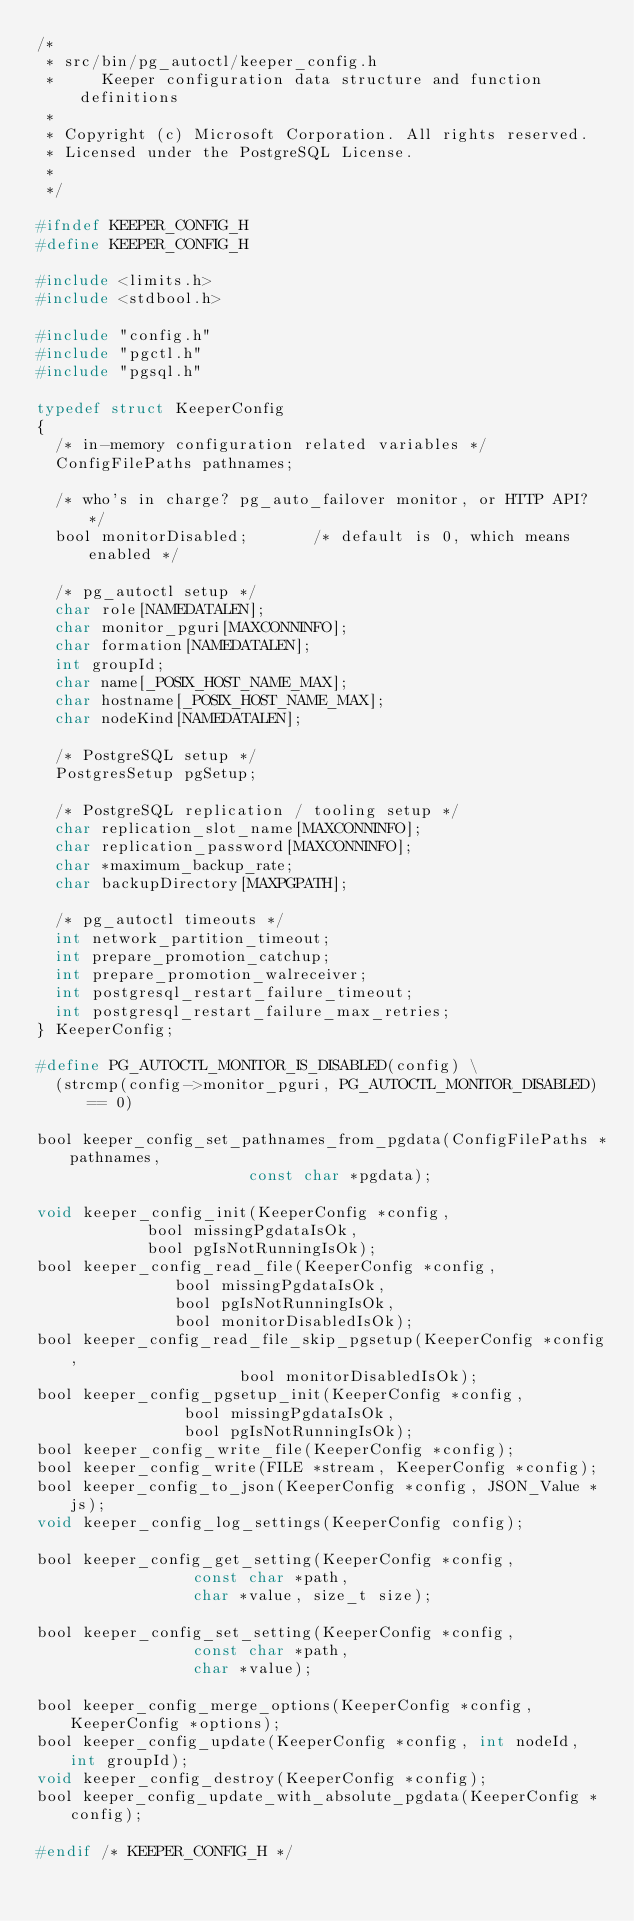<code> <loc_0><loc_0><loc_500><loc_500><_C_>/*
 * src/bin/pg_autoctl/keeper_config.h
 *     Keeper configuration data structure and function definitions
 *
 * Copyright (c) Microsoft Corporation. All rights reserved.
 * Licensed under the PostgreSQL License.
 *
 */

#ifndef KEEPER_CONFIG_H
#define KEEPER_CONFIG_H

#include <limits.h>
#include <stdbool.h>

#include "config.h"
#include "pgctl.h"
#include "pgsql.h"

typedef struct KeeperConfig
{
	/* in-memory configuration related variables */
	ConfigFilePaths pathnames;

	/* who's in charge? pg_auto_failover monitor, or HTTP API? */
	bool monitorDisabled;       /* default is 0, which means enabled */

	/* pg_autoctl setup */
	char role[NAMEDATALEN];
	char monitor_pguri[MAXCONNINFO];
	char formation[NAMEDATALEN];
	int groupId;
	char name[_POSIX_HOST_NAME_MAX];
	char hostname[_POSIX_HOST_NAME_MAX];
	char nodeKind[NAMEDATALEN];

	/* PostgreSQL setup */
	PostgresSetup pgSetup;

	/* PostgreSQL replication / tooling setup */
	char replication_slot_name[MAXCONNINFO];
	char replication_password[MAXCONNINFO];
	char *maximum_backup_rate;
	char backupDirectory[MAXPGPATH];

	/* pg_autoctl timeouts */
	int network_partition_timeout;
	int prepare_promotion_catchup;
	int prepare_promotion_walreceiver;
	int postgresql_restart_failure_timeout;
	int postgresql_restart_failure_max_retries;
} KeeperConfig;

#define PG_AUTOCTL_MONITOR_IS_DISABLED(config) \
	(strcmp(config->monitor_pguri, PG_AUTOCTL_MONITOR_DISABLED) == 0)

bool keeper_config_set_pathnames_from_pgdata(ConfigFilePaths *pathnames,
											 const char *pgdata);

void keeper_config_init(KeeperConfig *config,
						bool missingPgdataIsOk,
						bool pgIsNotRunningIsOk);
bool keeper_config_read_file(KeeperConfig *config,
							 bool missingPgdataIsOk,
							 bool pgIsNotRunningIsOk,
							 bool monitorDisabledIsOk);
bool keeper_config_read_file_skip_pgsetup(KeeperConfig *config,
										  bool monitorDisabledIsOk);
bool keeper_config_pgsetup_init(KeeperConfig *config,
								bool missingPgdataIsOk,
								bool pgIsNotRunningIsOk);
bool keeper_config_write_file(KeeperConfig *config);
bool keeper_config_write(FILE *stream, KeeperConfig *config);
bool keeper_config_to_json(KeeperConfig *config, JSON_Value *js);
void keeper_config_log_settings(KeeperConfig config);

bool keeper_config_get_setting(KeeperConfig *config,
							   const char *path,
							   char *value, size_t size);

bool keeper_config_set_setting(KeeperConfig *config,
							   const char *path,
							   char *value);

bool keeper_config_merge_options(KeeperConfig *config, KeeperConfig *options);
bool keeper_config_update(KeeperConfig *config, int nodeId, int groupId);
void keeper_config_destroy(KeeperConfig *config);
bool keeper_config_update_with_absolute_pgdata(KeeperConfig *config);

#endif /* KEEPER_CONFIG_H */
</code> 